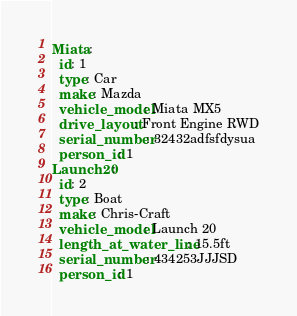<code> <loc_0><loc_0><loc_500><loc_500><_YAML_>Miata:
  id: 1
  type: Car
  make: Mazda
  vehicle_model: Miata MX5
  drive_layout: Front Engine RWD
  serial_number: 32432adfsfdysua
  person_id: 1
Launch20:
  id: 2
  type: Boat
  make: Chris-Craft
  vehicle_model: Launch 20
  length_at_water_line: 15.5ft
  serial_number: 434253JJJSD
  person_id: 1
</code> 